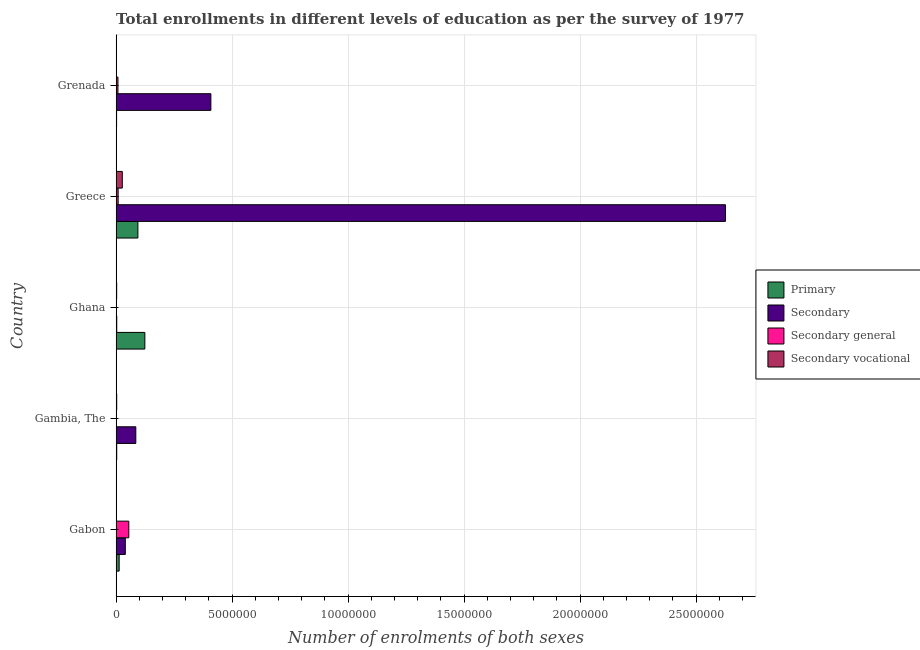How many different coloured bars are there?
Make the answer very short. 4. Are the number of bars per tick equal to the number of legend labels?
Ensure brevity in your answer.  Yes. Are the number of bars on each tick of the Y-axis equal?
Ensure brevity in your answer.  Yes. How many bars are there on the 2nd tick from the top?
Provide a succinct answer. 4. What is the label of the 4th group of bars from the top?
Provide a short and direct response. Gambia, The. In how many cases, is the number of bars for a given country not equal to the number of legend labels?
Make the answer very short. 0. What is the number of enrolments in secondary general education in Greece?
Your answer should be compact. 8.65e+04. Across all countries, what is the maximum number of enrolments in secondary general education?
Your answer should be compact. 5.46e+05. Across all countries, what is the minimum number of enrolments in primary education?
Your answer should be compact. 2.03e+04. In which country was the number of enrolments in secondary general education maximum?
Your answer should be very brief. Gabon. In which country was the number of enrolments in primary education minimum?
Make the answer very short. Grenada. What is the total number of enrolments in secondary vocational education in the graph?
Provide a succinct answer. 3.20e+05. What is the difference between the number of enrolments in primary education in Gambia, The and that in Ghana?
Your answer should be very brief. -1.21e+06. What is the difference between the number of enrolments in secondary vocational education in Grenada and the number of enrolments in secondary education in Greece?
Your answer should be very brief. -2.63e+07. What is the average number of enrolments in secondary vocational education per country?
Ensure brevity in your answer.  6.40e+04. What is the difference between the number of enrolments in secondary general education and number of enrolments in secondary education in Ghana?
Ensure brevity in your answer.  -1.32e+04. What is the ratio of the number of enrolments in secondary vocational education in Gambia, The to that in Greece?
Offer a very short reply. 0.09. Is the number of enrolments in primary education in Gabon less than that in Gambia, The?
Provide a succinct answer. No. What is the difference between the highest and the second highest number of enrolments in primary education?
Offer a very short reply. 3.00e+05. What is the difference between the highest and the lowest number of enrolments in secondary general education?
Make the answer very short. 5.36e+05. In how many countries, is the number of enrolments in secondary education greater than the average number of enrolments in secondary education taken over all countries?
Give a very brief answer. 1. Is it the case that in every country, the sum of the number of enrolments in primary education and number of enrolments in secondary education is greater than the sum of number of enrolments in secondary general education and number of enrolments in secondary vocational education?
Give a very brief answer. No. What does the 3rd bar from the top in Greece represents?
Ensure brevity in your answer.  Secondary. What does the 3rd bar from the bottom in Grenada represents?
Provide a short and direct response. Secondary general. How many bars are there?
Your answer should be very brief. 20. How many countries are there in the graph?
Your response must be concise. 5. What is the difference between two consecutive major ticks on the X-axis?
Your answer should be very brief. 5.00e+06. Does the graph contain any zero values?
Give a very brief answer. No. Where does the legend appear in the graph?
Provide a succinct answer. Center right. What is the title of the graph?
Your answer should be very brief. Total enrollments in different levels of education as per the survey of 1977. Does "Belgium" appear as one of the legend labels in the graph?
Provide a succinct answer. No. What is the label or title of the X-axis?
Offer a terse response. Number of enrolments of both sexes. What is the Number of enrolments of both sexes of Primary in Gabon?
Offer a very short reply. 1.30e+05. What is the Number of enrolments of both sexes in Secondary in Gabon?
Provide a short and direct response. 3.96e+05. What is the Number of enrolments of both sexes of Secondary general in Gabon?
Your answer should be compact. 5.46e+05. What is the Number of enrolments of both sexes in Secondary vocational in Gabon?
Offer a terse response. 392. What is the Number of enrolments of both sexes of Primary in Gambia, The?
Offer a terse response. 2.55e+04. What is the Number of enrolments of both sexes in Secondary in Gambia, The?
Ensure brevity in your answer.  8.48e+05. What is the Number of enrolments of both sexes in Secondary general in Gambia, The?
Provide a succinct answer. 1.01e+04. What is the Number of enrolments of both sexes of Secondary vocational in Gambia, The?
Give a very brief answer. 2.49e+04. What is the Number of enrolments of both sexes in Primary in Ghana?
Give a very brief answer. 1.24e+06. What is the Number of enrolments of both sexes in Secondary in Ghana?
Make the answer very short. 2.65e+04. What is the Number of enrolments of both sexes in Secondary general in Ghana?
Provide a succinct answer. 1.33e+04. What is the Number of enrolments of both sexes of Secondary vocational in Ghana?
Provide a short and direct response. 2.35e+04. What is the Number of enrolments of both sexes in Primary in Greece?
Provide a succinct answer. 9.38e+05. What is the Number of enrolments of both sexes in Secondary in Greece?
Your answer should be very brief. 2.63e+07. What is the Number of enrolments of both sexes of Secondary general in Greece?
Your answer should be compact. 8.65e+04. What is the Number of enrolments of both sexes of Secondary vocational in Greece?
Offer a very short reply. 2.66e+05. What is the Number of enrolments of both sexes of Primary in Grenada?
Your answer should be compact. 2.03e+04. What is the Number of enrolments of both sexes of Secondary in Grenada?
Make the answer very short. 4.08e+06. What is the Number of enrolments of both sexes of Secondary general in Grenada?
Provide a short and direct response. 7.85e+04. What is the Number of enrolments of both sexes in Secondary vocational in Grenada?
Ensure brevity in your answer.  5742. Across all countries, what is the maximum Number of enrolments of both sexes in Primary?
Ensure brevity in your answer.  1.24e+06. Across all countries, what is the maximum Number of enrolments of both sexes in Secondary?
Ensure brevity in your answer.  2.63e+07. Across all countries, what is the maximum Number of enrolments of both sexes of Secondary general?
Offer a terse response. 5.46e+05. Across all countries, what is the maximum Number of enrolments of both sexes in Secondary vocational?
Your answer should be compact. 2.66e+05. Across all countries, what is the minimum Number of enrolments of both sexes in Primary?
Offer a very short reply. 2.03e+04. Across all countries, what is the minimum Number of enrolments of both sexes of Secondary?
Your answer should be compact. 2.65e+04. Across all countries, what is the minimum Number of enrolments of both sexes in Secondary general?
Make the answer very short. 1.01e+04. Across all countries, what is the minimum Number of enrolments of both sexes of Secondary vocational?
Give a very brief answer. 392. What is the total Number of enrolments of both sexes of Primary in the graph?
Make the answer very short. 2.35e+06. What is the total Number of enrolments of both sexes of Secondary in the graph?
Keep it short and to the point. 3.16e+07. What is the total Number of enrolments of both sexes of Secondary general in the graph?
Your answer should be compact. 7.35e+05. What is the total Number of enrolments of both sexes of Secondary vocational in the graph?
Offer a very short reply. 3.20e+05. What is the difference between the Number of enrolments of both sexes in Primary in Gabon and that in Gambia, The?
Keep it short and to the point. 1.05e+05. What is the difference between the Number of enrolments of both sexes in Secondary in Gabon and that in Gambia, The?
Your response must be concise. -4.52e+05. What is the difference between the Number of enrolments of both sexes in Secondary general in Gabon and that in Gambia, The?
Give a very brief answer. 5.36e+05. What is the difference between the Number of enrolments of both sexes in Secondary vocational in Gabon and that in Gambia, The?
Your response must be concise. -2.45e+04. What is the difference between the Number of enrolments of both sexes in Primary in Gabon and that in Ghana?
Your answer should be very brief. -1.11e+06. What is the difference between the Number of enrolments of both sexes in Secondary in Gabon and that in Ghana?
Make the answer very short. 3.69e+05. What is the difference between the Number of enrolments of both sexes in Secondary general in Gabon and that in Ghana?
Provide a succinct answer. 5.33e+05. What is the difference between the Number of enrolments of both sexes in Secondary vocational in Gabon and that in Ghana?
Ensure brevity in your answer.  -2.31e+04. What is the difference between the Number of enrolments of both sexes in Primary in Gabon and that in Greece?
Keep it short and to the point. -8.07e+05. What is the difference between the Number of enrolments of both sexes of Secondary in Gabon and that in Greece?
Provide a short and direct response. -2.59e+07. What is the difference between the Number of enrolments of both sexes in Secondary general in Gabon and that in Greece?
Ensure brevity in your answer.  4.60e+05. What is the difference between the Number of enrolments of both sexes of Secondary vocational in Gabon and that in Greece?
Provide a short and direct response. -2.65e+05. What is the difference between the Number of enrolments of both sexes of Primary in Gabon and that in Grenada?
Your answer should be compact. 1.10e+05. What is the difference between the Number of enrolments of both sexes of Secondary in Gabon and that in Grenada?
Provide a succinct answer. -3.69e+06. What is the difference between the Number of enrolments of both sexes of Secondary general in Gabon and that in Grenada?
Make the answer very short. 4.68e+05. What is the difference between the Number of enrolments of both sexes of Secondary vocational in Gabon and that in Grenada?
Your answer should be very brief. -5350. What is the difference between the Number of enrolments of both sexes of Primary in Gambia, The and that in Ghana?
Your answer should be very brief. -1.21e+06. What is the difference between the Number of enrolments of both sexes in Secondary in Gambia, The and that in Ghana?
Keep it short and to the point. 8.22e+05. What is the difference between the Number of enrolments of both sexes of Secondary general in Gambia, The and that in Ghana?
Provide a short and direct response. -3212. What is the difference between the Number of enrolments of both sexes in Secondary vocational in Gambia, The and that in Ghana?
Your response must be concise. 1378. What is the difference between the Number of enrolments of both sexes in Primary in Gambia, The and that in Greece?
Your response must be concise. -9.12e+05. What is the difference between the Number of enrolments of both sexes of Secondary in Gambia, The and that in Greece?
Ensure brevity in your answer.  -2.54e+07. What is the difference between the Number of enrolments of both sexes of Secondary general in Gambia, The and that in Greece?
Provide a succinct answer. -7.64e+04. What is the difference between the Number of enrolments of both sexes in Secondary vocational in Gambia, The and that in Greece?
Keep it short and to the point. -2.41e+05. What is the difference between the Number of enrolments of both sexes in Primary in Gambia, The and that in Grenada?
Provide a short and direct response. 5254. What is the difference between the Number of enrolments of both sexes in Secondary in Gambia, The and that in Grenada?
Provide a succinct answer. -3.24e+06. What is the difference between the Number of enrolments of both sexes in Secondary general in Gambia, The and that in Grenada?
Your answer should be compact. -6.84e+04. What is the difference between the Number of enrolments of both sexes in Secondary vocational in Gambia, The and that in Grenada?
Give a very brief answer. 1.92e+04. What is the difference between the Number of enrolments of both sexes in Primary in Ghana and that in Greece?
Keep it short and to the point. 3.00e+05. What is the difference between the Number of enrolments of both sexes of Secondary in Ghana and that in Greece?
Your answer should be very brief. -2.62e+07. What is the difference between the Number of enrolments of both sexes of Secondary general in Ghana and that in Greece?
Offer a terse response. -7.32e+04. What is the difference between the Number of enrolments of both sexes of Secondary vocational in Ghana and that in Greece?
Your answer should be very brief. -2.42e+05. What is the difference between the Number of enrolments of both sexes of Primary in Ghana and that in Grenada?
Provide a succinct answer. 1.22e+06. What is the difference between the Number of enrolments of both sexes in Secondary in Ghana and that in Grenada?
Provide a short and direct response. -4.06e+06. What is the difference between the Number of enrolments of both sexes in Secondary general in Ghana and that in Grenada?
Your answer should be compact. -6.52e+04. What is the difference between the Number of enrolments of both sexes in Secondary vocational in Ghana and that in Grenada?
Your answer should be very brief. 1.78e+04. What is the difference between the Number of enrolments of both sexes in Primary in Greece and that in Grenada?
Offer a very short reply. 9.18e+05. What is the difference between the Number of enrolments of both sexes of Secondary in Greece and that in Grenada?
Provide a succinct answer. 2.22e+07. What is the difference between the Number of enrolments of both sexes in Secondary general in Greece and that in Grenada?
Provide a short and direct response. 8033. What is the difference between the Number of enrolments of both sexes in Secondary vocational in Greece and that in Grenada?
Give a very brief answer. 2.60e+05. What is the difference between the Number of enrolments of both sexes of Primary in Gabon and the Number of enrolments of both sexes of Secondary in Gambia, The?
Provide a short and direct response. -7.18e+05. What is the difference between the Number of enrolments of both sexes in Primary in Gabon and the Number of enrolments of both sexes in Secondary general in Gambia, The?
Provide a succinct answer. 1.20e+05. What is the difference between the Number of enrolments of both sexes of Primary in Gabon and the Number of enrolments of both sexes of Secondary vocational in Gambia, The?
Provide a succinct answer. 1.05e+05. What is the difference between the Number of enrolments of both sexes in Secondary in Gabon and the Number of enrolments of both sexes in Secondary general in Gambia, The?
Make the answer very short. 3.86e+05. What is the difference between the Number of enrolments of both sexes in Secondary in Gabon and the Number of enrolments of both sexes in Secondary vocational in Gambia, The?
Provide a succinct answer. 3.71e+05. What is the difference between the Number of enrolments of both sexes in Secondary general in Gabon and the Number of enrolments of both sexes in Secondary vocational in Gambia, The?
Provide a succinct answer. 5.21e+05. What is the difference between the Number of enrolments of both sexes in Primary in Gabon and the Number of enrolments of both sexes in Secondary in Ghana?
Your answer should be very brief. 1.04e+05. What is the difference between the Number of enrolments of both sexes in Primary in Gabon and the Number of enrolments of both sexes in Secondary general in Ghana?
Offer a very short reply. 1.17e+05. What is the difference between the Number of enrolments of both sexes in Primary in Gabon and the Number of enrolments of both sexes in Secondary vocational in Ghana?
Keep it short and to the point. 1.07e+05. What is the difference between the Number of enrolments of both sexes in Secondary in Gabon and the Number of enrolments of both sexes in Secondary general in Ghana?
Give a very brief answer. 3.82e+05. What is the difference between the Number of enrolments of both sexes of Secondary in Gabon and the Number of enrolments of both sexes of Secondary vocational in Ghana?
Ensure brevity in your answer.  3.72e+05. What is the difference between the Number of enrolments of both sexes in Secondary general in Gabon and the Number of enrolments of both sexes in Secondary vocational in Ghana?
Your response must be concise. 5.23e+05. What is the difference between the Number of enrolments of both sexes in Primary in Gabon and the Number of enrolments of both sexes in Secondary in Greece?
Your answer should be very brief. -2.61e+07. What is the difference between the Number of enrolments of both sexes in Primary in Gabon and the Number of enrolments of both sexes in Secondary general in Greece?
Make the answer very short. 4.39e+04. What is the difference between the Number of enrolments of both sexes in Primary in Gabon and the Number of enrolments of both sexes in Secondary vocational in Greece?
Keep it short and to the point. -1.35e+05. What is the difference between the Number of enrolments of both sexes in Secondary in Gabon and the Number of enrolments of both sexes in Secondary general in Greece?
Provide a short and direct response. 3.09e+05. What is the difference between the Number of enrolments of both sexes in Secondary in Gabon and the Number of enrolments of both sexes in Secondary vocational in Greece?
Your answer should be compact. 1.30e+05. What is the difference between the Number of enrolments of both sexes of Secondary general in Gabon and the Number of enrolments of both sexes of Secondary vocational in Greece?
Ensure brevity in your answer.  2.81e+05. What is the difference between the Number of enrolments of both sexes of Primary in Gabon and the Number of enrolments of both sexes of Secondary in Grenada?
Provide a succinct answer. -3.95e+06. What is the difference between the Number of enrolments of both sexes of Primary in Gabon and the Number of enrolments of both sexes of Secondary general in Grenada?
Your answer should be very brief. 5.19e+04. What is the difference between the Number of enrolments of both sexes in Primary in Gabon and the Number of enrolments of both sexes in Secondary vocational in Grenada?
Make the answer very short. 1.25e+05. What is the difference between the Number of enrolments of both sexes in Secondary in Gabon and the Number of enrolments of both sexes in Secondary general in Grenada?
Make the answer very short. 3.17e+05. What is the difference between the Number of enrolments of both sexes in Secondary in Gabon and the Number of enrolments of both sexes in Secondary vocational in Grenada?
Offer a very short reply. 3.90e+05. What is the difference between the Number of enrolments of both sexes of Secondary general in Gabon and the Number of enrolments of both sexes of Secondary vocational in Grenada?
Provide a succinct answer. 5.41e+05. What is the difference between the Number of enrolments of both sexes of Primary in Gambia, The and the Number of enrolments of both sexes of Secondary in Ghana?
Your answer should be compact. -993. What is the difference between the Number of enrolments of both sexes in Primary in Gambia, The and the Number of enrolments of both sexes in Secondary general in Ghana?
Provide a short and direct response. 1.22e+04. What is the difference between the Number of enrolments of both sexes of Primary in Gambia, The and the Number of enrolments of both sexes of Secondary vocational in Ghana?
Provide a succinct answer. 1992. What is the difference between the Number of enrolments of both sexes of Secondary in Gambia, The and the Number of enrolments of both sexes of Secondary general in Ghana?
Provide a short and direct response. 8.35e+05. What is the difference between the Number of enrolments of both sexes of Secondary in Gambia, The and the Number of enrolments of both sexes of Secondary vocational in Ghana?
Provide a short and direct response. 8.25e+05. What is the difference between the Number of enrolments of both sexes in Secondary general in Gambia, The and the Number of enrolments of both sexes in Secondary vocational in Ghana?
Offer a terse response. -1.34e+04. What is the difference between the Number of enrolments of both sexes in Primary in Gambia, The and the Number of enrolments of both sexes in Secondary in Greece?
Your answer should be very brief. -2.62e+07. What is the difference between the Number of enrolments of both sexes in Primary in Gambia, The and the Number of enrolments of both sexes in Secondary general in Greece?
Offer a terse response. -6.10e+04. What is the difference between the Number of enrolments of both sexes in Primary in Gambia, The and the Number of enrolments of both sexes in Secondary vocational in Greece?
Ensure brevity in your answer.  -2.40e+05. What is the difference between the Number of enrolments of both sexes of Secondary in Gambia, The and the Number of enrolments of both sexes of Secondary general in Greece?
Provide a short and direct response. 7.62e+05. What is the difference between the Number of enrolments of both sexes of Secondary in Gambia, The and the Number of enrolments of both sexes of Secondary vocational in Greece?
Keep it short and to the point. 5.83e+05. What is the difference between the Number of enrolments of both sexes of Secondary general in Gambia, The and the Number of enrolments of both sexes of Secondary vocational in Greece?
Offer a terse response. -2.55e+05. What is the difference between the Number of enrolments of both sexes of Primary in Gambia, The and the Number of enrolments of both sexes of Secondary in Grenada?
Provide a succinct answer. -4.06e+06. What is the difference between the Number of enrolments of both sexes of Primary in Gambia, The and the Number of enrolments of both sexes of Secondary general in Grenada?
Provide a succinct answer. -5.29e+04. What is the difference between the Number of enrolments of both sexes of Primary in Gambia, The and the Number of enrolments of both sexes of Secondary vocational in Grenada?
Your answer should be very brief. 1.98e+04. What is the difference between the Number of enrolments of both sexes of Secondary in Gambia, The and the Number of enrolments of both sexes of Secondary general in Grenada?
Your answer should be very brief. 7.70e+05. What is the difference between the Number of enrolments of both sexes in Secondary in Gambia, The and the Number of enrolments of both sexes in Secondary vocational in Grenada?
Your response must be concise. 8.42e+05. What is the difference between the Number of enrolments of both sexes in Secondary general in Gambia, The and the Number of enrolments of both sexes in Secondary vocational in Grenada?
Make the answer very short. 4346. What is the difference between the Number of enrolments of both sexes in Primary in Ghana and the Number of enrolments of both sexes in Secondary in Greece?
Make the answer very short. -2.50e+07. What is the difference between the Number of enrolments of both sexes of Primary in Ghana and the Number of enrolments of both sexes of Secondary general in Greece?
Give a very brief answer. 1.15e+06. What is the difference between the Number of enrolments of both sexes of Primary in Ghana and the Number of enrolments of both sexes of Secondary vocational in Greece?
Provide a succinct answer. 9.72e+05. What is the difference between the Number of enrolments of both sexes of Secondary in Ghana and the Number of enrolments of both sexes of Secondary general in Greece?
Provide a succinct answer. -6.00e+04. What is the difference between the Number of enrolments of both sexes in Secondary in Ghana and the Number of enrolments of both sexes in Secondary vocational in Greece?
Make the answer very short. -2.39e+05. What is the difference between the Number of enrolments of both sexes of Secondary general in Ghana and the Number of enrolments of both sexes of Secondary vocational in Greece?
Give a very brief answer. -2.52e+05. What is the difference between the Number of enrolments of both sexes of Primary in Ghana and the Number of enrolments of both sexes of Secondary in Grenada?
Offer a terse response. -2.85e+06. What is the difference between the Number of enrolments of both sexes of Primary in Ghana and the Number of enrolments of both sexes of Secondary general in Grenada?
Your answer should be very brief. 1.16e+06. What is the difference between the Number of enrolments of both sexes of Primary in Ghana and the Number of enrolments of both sexes of Secondary vocational in Grenada?
Provide a short and direct response. 1.23e+06. What is the difference between the Number of enrolments of both sexes in Secondary in Ghana and the Number of enrolments of both sexes in Secondary general in Grenada?
Your answer should be compact. -5.20e+04. What is the difference between the Number of enrolments of both sexes in Secondary in Ghana and the Number of enrolments of both sexes in Secondary vocational in Grenada?
Your answer should be compact. 2.08e+04. What is the difference between the Number of enrolments of both sexes in Secondary general in Ghana and the Number of enrolments of both sexes in Secondary vocational in Grenada?
Provide a succinct answer. 7558. What is the difference between the Number of enrolments of both sexes in Primary in Greece and the Number of enrolments of both sexes in Secondary in Grenada?
Keep it short and to the point. -3.15e+06. What is the difference between the Number of enrolments of both sexes in Primary in Greece and the Number of enrolments of both sexes in Secondary general in Grenada?
Your answer should be compact. 8.59e+05. What is the difference between the Number of enrolments of both sexes in Primary in Greece and the Number of enrolments of both sexes in Secondary vocational in Grenada?
Ensure brevity in your answer.  9.32e+05. What is the difference between the Number of enrolments of both sexes of Secondary in Greece and the Number of enrolments of both sexes of Secondary general in Grenada?
Your answer should be compact. 2.62e+07. What is the difference between the Number of enrolments of both sexes in Secondary in Greece and the Number of enrolments of both sexes in Secondary vocational in Grenada?
Your answer should be very brief. 2.63e+07. What is the difference between the Number of enrolments of both sexes in Secondary general in Greece and the Number of enrolments of both sexes in Secondary vocational in Grenada?
Provide a succinct answer. 8.08e+04. What is the average Number of enrolments of both sexes in Primary per country?
Ensure brevity in your answer.  4.70e+05. What is the average Number of enrolments of both sexes of Secondary per country?
Your answer should be compact. 6.32e+06. What is the average Number of enrolments of both sexes of Secondary general per country?
Your response must be concise. 1.47e+05. What is the average Number of enrolments of both sexes of Secondary vocational per country?
Make the answer very short. 6.40e+04. What is the difference between the Number of enrolments of both sexes in Primary and Number of enrolments of both sexes in Secondary in Gabon?
Offer a very short reply. -2.65e+05. What is the difference between the Number of enrolments of both sexes in Primary and Number of enrolments of both sexes in Secondary general in Gabon?
Your answer should be very brief. -4.16e+05. What is the difference between the Number of enrolments of both sexes in Primary and Number of enrolments of both sexes in Secondary vocational in Gabon?
Keep it short and to the point. 1.30e+05. What is the difference between the Number of enrolments of both sexes of Secondary and Number of enrolments of both sexes of Secondary general in Gabon?
Provide a succinct answer. -1.51e+05. What is the difference between the Number of enrolments of both sexes of Secondary and Number of enrolments of both sexes of Secondary vocational in Gabon?
Your answer should be compact. 3.95e+05. What is the difference between the Number of enrolments of both sexes in Secondary general and Number of enrolments of both sexes in Secondary vocational in Gabon?
Offer a terse response. 5.46e+05. What is the difference between the Number of enrolments of both sexes in Primary and Number of enrolments of both sexes in Secondary in Gambia, The?
Ensure brevity in your answer.  -8.23e+05. What is the difference between the Number of enrolments of both sexes in Primary and Number of enrolments of both sexes in Secondary general in Gambia, The?
Ensure brevity in your answer.  1.54e+04. What is the difference between the Number of enrolments of both sexes of Primary and Number of enrolments of both sexes of Secondary vocational in Gambia, The?
Offer a terse response. 614. What is the difference between the Number of enrolments of both sexes in Secondary and Number of enrolments of both sexes in Secondary general in Gambia, The?
Your answer should be very brief. 8.38e+05. What is the difference between the Number of enrolments of both sexes in Secondary and Number of enrolments of both sexes in Secondary vocational in Gambia, The?
Offer a very short reply. 8.23e+05. What is the difference between the Number of enrolments of both sexes of Secondary general and Number of enrolments of both sexes of Secondary vocational in Gambia, The?
Give a very brief answer. -1.48e+04. What is the difference between the Number of enrolments of both sexes in Primary and Number of enrolments of both sexes in Secondary in Ghana?
Provide a short and direct response. 1.21e+06. What is the difference between the Number of enrolments of both sexes in Primary and Number of enrolments of both sexes in Secondary general in Ghana?
Ensure brevity in your answer.  1.22e+06. What is the difference between the Number of enrolments of both sexes of Primary and Number of enrolments of both sexes of Secondary vocational in Ghana?
Offer a terse response. 1.21e+06. What is the difference between the Number of enrolments of both sexes of Secondary and Number of enrolments of both sexes of Secondary general in Ghana?
Offer a terse response. 1.32e+04. What is the difference between the Number of enrolments of both sexes in Secondary and Number of enrolments of both sexes in Secondary vocational in Ghana?
Give a very brief answer. 2985. What is the difference between the Number of enrolments of both sexes in Secondary general and Number of enrolments of both sexes in Secondary vocational in Ghana?
Offer a very short reply. -1.02e+04. What is the difference between the Number of enrolments of both sexes of Primary and Number of enrolments of both sexes of Secondary in Greece?
Ensure brevity in your answer.  -2.53e+07. What is the difference between the Number of enrolments of both sexes in Primary and Number of enrolments of both sexes in Secondary general in Greece?
Provide a succinct answer. 8.51e+05. What is the difference between the Number of enrolments of both sexes of Primary and Number of enrolments of both sexes of Secondary vocational in Greece?
Your answer should be very brief. 6.72e+05. What is the difference between the Number of enrolments of both sexes in Secondary and Number of enrolments of both sexes in Secondary general in Greece?
Your answer should be very brief. 2.62e+07. What is the difference between the Number of enrolments of both sexes in Secondary and Number of enrolments of both sexes in Secondary vocational in Greece?
Make the answer very short. 2.60e+07. What is the difference between the Number of enrolments of both sexes in Secondary general and Number of enrolments of both sexes in Secondary vocational in Greece?
Provide a short and direct response. -1.79e+05. What is the difference between the Number of enrolments of both sexes in Primary and Number of enrolments of both sexes in Secondary in Grenada?
Offer a very short reply. -4.06e+06. What is the difference between the Number of enrolments of both sexes in Primary and Number of enrolments of both sexes in Secondary general in Grenada?
Offer a very short reply. -5.82e+04. What is the difference between the Number of enrolments of both sexes of Primary and Number of enrolments of both sexes of Secondary vocational in Grenada?
Your response must be concise. 1.45e+04. What is the difference between the Number of enrolments of both sexes of Secondary and Number of enrolments of both sexes of Secondary general in Grenada?
Give a very brief answer. 4.01e+06. What is the difference between the Number of enrolments of both sexes of Secondary and Number of enrolments of both sexes of Secondary vocational in Grenada?
Provide a succinct answer. 4.08e+06. What is the difference between the Number of enrolments of both sexes of Secondary general and Number of enrolments of both sexes of Secondary vocational in Grenada?
Provide a short and direct response. 7.27e+04. What is the ratio of the Number of enrolments of both sexes in Primary in Gabon to that in Gambia, The?
Offer a very short reply. 5.11. What is the ratio of the Number of enrolments of both sexes in Secondary in Gabon to that in Gambia, The?
Keep it short and to the point. 0.47. What is the ratio of the Number of enrolments of both sexes in Secondary general in Gabon to that in Gambia, The?
Your answer should be compact. 54.16. What is the ratio of the Number of enrolments of both sexes of Secondary vocational in Gabon to that in Gambia, The?
Offer a terse response. 0.02. What is the ratio of the Number of enrolments of both sexes in Primary in Gabon to that in Ghana?
Keep it short and to the point. 0.11. What is the ratio of the Number of enrolments of both sexes of Secondary in Gabon to that in Ghana?
Give a very brief answer. 14.93. What is the ratio of the Number of enrolments of both sexes of Secondary general in Gabon to that in Ghana?
Offer a very short reply. 41.08. What is the ratio of the Number of enrolments of both sexes in Secondary vocational in Gabon to that in Ghana?
Your response must be concise. 0.02. What is the ratio of the Number of enrolments of both sexes of Primary in Gabon to that in Greece?
Provide a short and direct response. 0.14. What is the ratio of the Number of enrolments of both sexes in Secondary in Gabon to that in Greece?
Make the answer very short. 0.02. What is the ratio of the Number of enrolments of both sexes of Secondary general in Gabon to that in Greece?
Your response must be concise. 6.32. What is the ratio of the Number of enrolments of both sexes of Secondary vocational in Gabon to that in Greece?
Offer a very short reply. 0. What is the ratio of the Number of enrolments of both sexes in Primary in Gabon to that in Grenada?
Provide a short and direct response. 6.44. What is the ratio of the Number of enrolments of both sexes in Secondary in Gabon to that in Grenada?
Ensure brevity in your answer.  0.1. What is the ratio of the Number of enrolments of both sexes of Secondary general in Gabon to that in Grenada?
Provide a succinct answer. 6.96. What is the ratio of the Number of enrolments of both sexes in Secondary vocational in Gabon to that in Grenada?
Your answer should be compact. 0.07. What is the ratio of the Number of enrolments of both sexes of Primary in Gambia, The to that in Ghana?
Provide a succinct answer. 0.02. What is the ratio of the Number of enrolments of both sexes of Secondary in Gambia, The to that in Ghana?
Offer a very short reply. 32. What is the ratio of the Number of enrolments of both sexes in Secondary general in Gambia, The to that in Ghana?
Provide a succinct answer. 0.76. What is the ratio of the Number of enrolments of both sexes of Secondary vocational in Gambia, The to that in Ghana?
Ensure brevity in your answer.  1.06. What is the ratio of the Number of enrolments of both sexes in Primary in Gambia, The to that in Greece?
Your response must be concise. 0.03. What is the ratio of the Number of enrolments of both sexes of Secondary in Gambia, The to that in Greece?
Provide a succinct answer. 0.03. What is the ratio of the Number of enrolments of both sexes of Secondary general in Gambia, The to that in Greece?
Keep it short and to the point. 0.12. What is the ratio of the Number of enrolments of both sexes of Secondary vocational in Gambia, The to that in Greece?
Keep it short and to the point. 0.09. What is the ratio of the Number of enrolments of both sexes in Primary in Gambia, The to that in Grenada?
Your response must be concise. 1.26. What is the ratio of the Number of enrolments of both sexes in Secondary in Gambia, The to that in Grenada?
Your response must be concise. 0.21. What is the ratio of the Number of enrolments of both sexes of Secondary general in Gambia, The to that in Grenada?
Your answer should be compact. 0.13. What is the ratio of the Number of enrolments of both sexes of Secondary vocational in Gambia, The to that in Grenada?
Your answer should be very brief. 4.34. What is the ratio of the Number of enrolments of both sexes in Primary in Ghana to that in Greece?
Keep it short and to the point. 1.32. What is the ratio of the Number of enrolments of both sexes of Secondary general in Ghana to that in Greece?
Give a very brief answer. 0.15. What is the ratio of the Number of enrolments of both sexes of Secondary vocational in Ghana to that in Greece?
Give a very brief answer. 0.09. What is the ratio of the Number of enrolments of both sexes in Primary in Ghana to that in Grenada?
Offer a terse response. 61.09. What is the ratio of the Number of enrolments of both sexes in Secondary in Ghana to that in Grenada?
Keep it short and to the point. 0.01. What is the ratio of the Number of enrolments of both sexes of Secondary general in Ghana to that in Grenada?
Keep it short and to the point. 0.17. What is the ratio of the Number of enrolments of both sexes of Secondary vocational in Ghana to that in Grenada?
Offer a terse response. 4.1. What is the ratio of the Number of enrolments of both sexes in Primary in Greece to that in Grenada?
Your response must be concise. 46.29. What is the ratio of the Number of enrolments of both sexes of Secondary in Greece to that in Grenada?
Offer a very short reply. 6.43. What is the ratio of the Number of enrolments of both sexes in Secondary general in Greece to that in Grenada?
Your answer should be compact. 1.1. What is the ratio of the Number of enrolments of both sexes in Secondary vocational in Greece to that in Grenada?
Make the answer very short. 46.25. What is the difference between the highest and the second highest Number of enrolments of both sexes in Primary?
Your answer should be very brief. 3.00e+05. What is the difference between the highest and the second highest Number of enrolments of both sexes of Secondary?
Offer a terse response. 2.22e+07. What is the difference between the highest and the second highest Number of enrolments of both sexes in Secondary general?
Your answer should be compact. 4.60e+05. What is the difference between the highest and the second highest Number of enrolments of both sexes of Secondary vocational?
Give a very brief answer. 2.41e+05. What is the difference between the highest and the lowest Number of enrolments of both sexes in Primary?
Your answer should be very brief. 1.22e+06. What is the difference between the highest and the lowest Number of enrolments of both sexes of Secondary?
Your response must be concise. 2.62e+07. What is the difference between the highest and the lowest Number of enrolments of both sexes in Secondary general?
Ensure brevity in your answer.  5.36e+05. What is the difference between the highest and the lowest Number of enrolments of both sexes of Secondary vocational?
Give a very brief answer. 2.65e+05. 